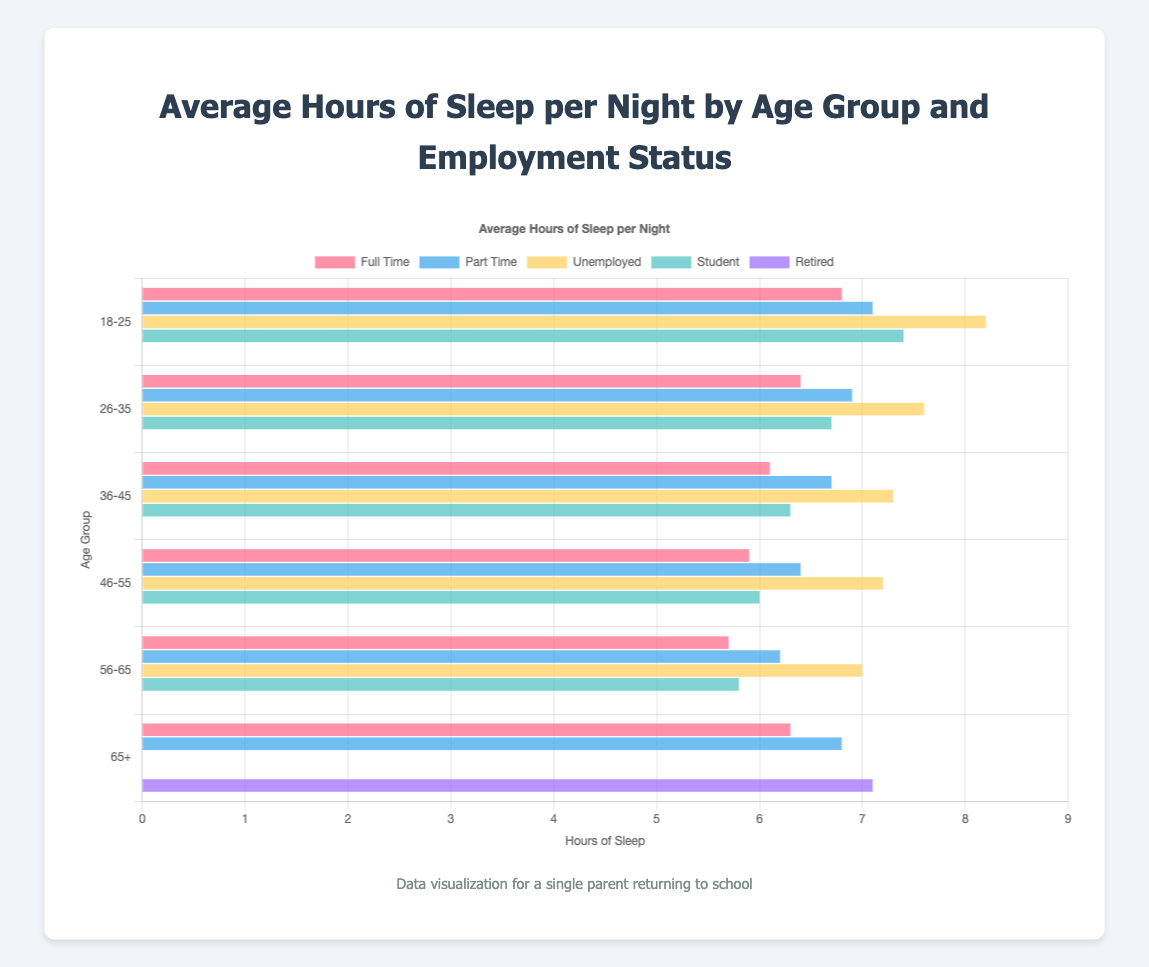Which age group has the highest average hours of sleep for part-time employees? Look for the "Part Time" bars across all age groups and compare their lengths. The highest value is 7.1 hours in the 18-25 age group.
Answer: 18-25 What is the difference in average sleep hours between full-time employees and unemployed individuals in the 36-45 age group? Identify the "Full Time" and "Unemployed" bars for the 36-45 age group. The values are 6.1 and 7.3, respectively. Calculate the difference: 7.3 - 6.1 = 1.2 hours.
Answer: 1.2 hours What's the average sleep duration for students in the 26-35 age group? Locate the "Student" bar in the 26-35 age group, which is 6.7 hours. There’s only one value to consider.
Answer: 6.7 hours Which employment status shows the most sleep for people aged 46-55? Compare the lengths of the bars (hours) for each employment status within the 46-55 age group. The highest bar represents the "Unemployed" status with 7.2 hours.
Answer: Unemployed How does the sleep duration of retired individuals in the 65+ age group compare to that of full-time employees in the same age group? Look at the bars for "Retired" and "Full Time" in the 65+ age group. "Retired" has 7.1 hours, and "Full Time" has 6.3 hours. Compare the two values visually.
Answer: Retired individuals sleep more What is the average sleep duration for part-time workers across all age groups? Identify the "Part Time" bars for all age groups: 7.1, 6.9, 6.7, 6.4, 6.2, 6.8. Sum these values (7.1 + 6.9 + 6.7 + 6.4 + 6.2 + 6.8 = 40.1), then divide by the number of age groups (6). The average is 40.1/6 ≈ 6.68 hours.
Answer: 6.68 hours In which age group do full-time employees get the least sleep? Compare the "Full Time" bars across all age groups. The smallest value is in the 56-65 age group with 5.7 hours.
Answer: 56-65 Are students in the 18-25 age group getting more sleep than full-time employees in the same group? Compare the "Student" and "Full Time" bars in the 18-25 age group. The values are 7.4 hours for students and 6.8 hours for full-time employees.
Answer: Yes What's the relationship between the sleep duration of unemployed individuals in the 18-25 and 26-35 age groups? Identify the "Unemployed" bars for the 18-25 and 26-35 age groups. The values are 8.2 and 7.6, respectively. Compare the two values to see which is higher.
Answer: 18-25 sleeps more Which age group has the smallest difference between full-time and part-time sleep durations? Calculate the differences for each age group by subtracting the full-time sleep from the part-time sleep durations: 18-25 (7.1-6.8=0.3), 26-35 (6.9-6.4=0.5), 36-45 (6.7-6.1=0.6), 46-55 (6.4-5.9=0.5), 56-65 (6.2-5.7=0.5), 65+ (6.8-6.3=0.5). The smallest difference is 0.3 hours in the 18-25 age group.
Answer: 18-25 